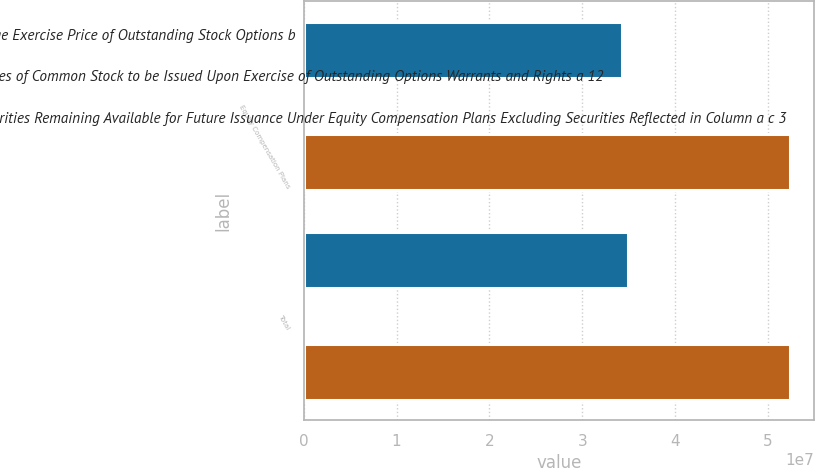<chart> <loc_0><loc_0><loc_500><loc_500><stacked_bar_chart><ecel><fcel>Equity Compensation Plans<fcel>Total<nl><fcel>WeightedAverage Exercise Price of Outstanding Stock Options b<fcel>3.43174e+07<fcel>3.49299e+07<nl><fcel>Number of Shares of Common Stock to be Issued Upon Exercise of Outstanding Options Warrants and Rights a 12<fcel>16.11<fcel>16.31<nl><fcel>Number of Securities Remaining Available for Future Issuance Under Equity Compensation Plans Excluding Securities Reflected in Column a c 3<fcel>5.23593e+07<fcel>5.23593e+07<nl></chart> 